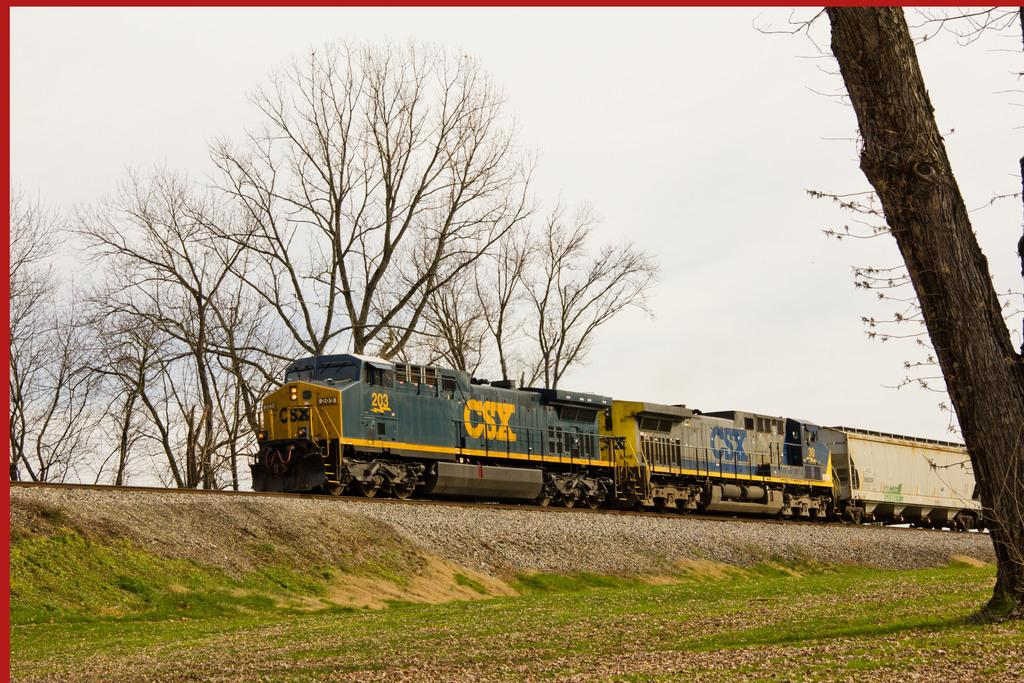What is the main subject of the image? The main subject of the image is a train. Where is the train located in the image? The train is standing on railway tracks. What is the ground covered with in the image? The ground is covered with grass. What can be seen in the background of the image? There are trees visible in the background of the image. What type of whistle can be heard coming from the train in the image? There is no sound present in the image, so it is not possible to determine if a whistle can be heard. 